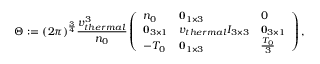<formula> <loc_0><loc_0><loc_500><loc_500>\Theta \colon = ( 2 \pi ) ^ { \frac { 3 } { 4 } } \frac { v _ { t h e r m a l } ^ { 3 } } { n _ { 0 } } \left ( \begin{array} { l l l } { n _ { 0 } } & { 0 _ { 1 \times 3 } } & { 0 } \\ { 0 _ { 3 \times 1 } } & { v _ { t h e r m a l } I _ { 3 \times 3 } } & { 0 _ { 3 \times 1 } } \\ { - T _ { 0 } } & { 0 _ { 1 \times 3 } } & { \frac { T _ { 0 } } { 3 } } \end{array} \right ) ,</formula> 